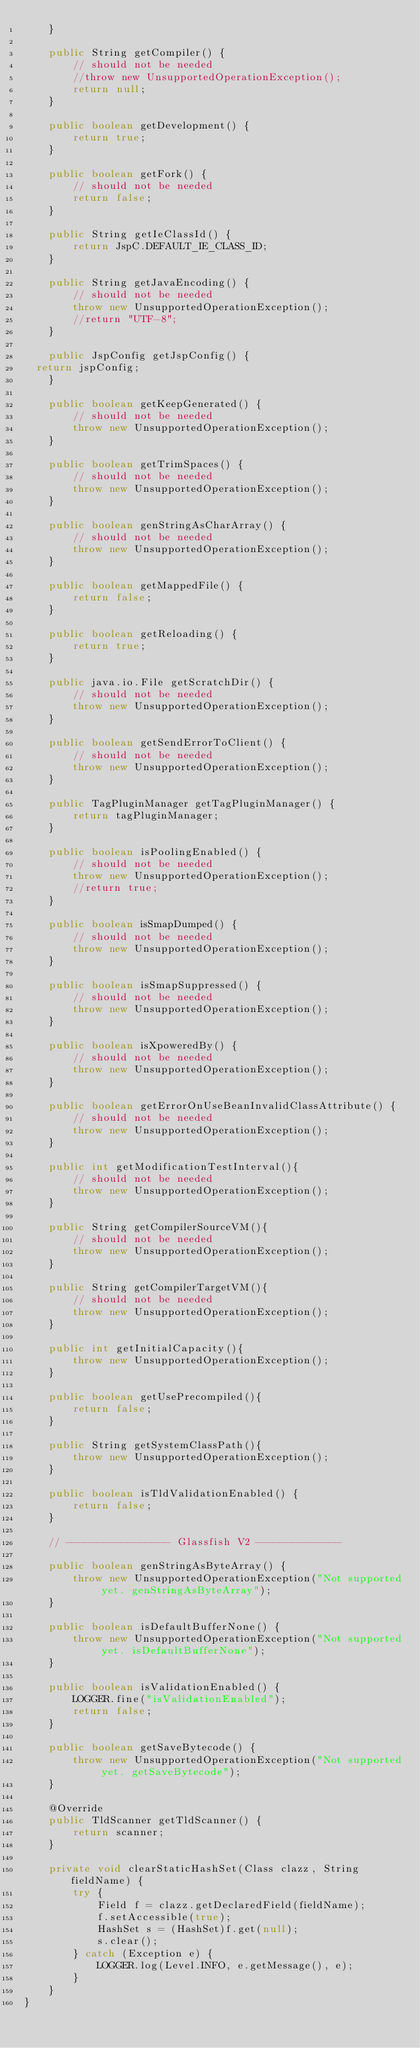Convert code to text. <code><loc_0><loc_0><loc_500><loc_500><_Java_>    }
    
    public String getCompiler() {
        // should not be needed
        //throw new UnsupportedOperationException();
        return null;
    }
    
    public boolean getDevelopment() {
        return true;
    }
    
    public boolean getFork() {
        // should not be needed
        return false;
    }
    
    public String getIeClassId() {
        return JspC.DEFAULT_IE_CLASS_ID;
    }
    
    public String getJavaEncoding() {
        // should not be needed
        throw new UnsupportedOperationException();
        //return "UTF-8";
    }
    
    public JspConfig getJspConfig() {
	return jspConfig;
    }
    
    public boolean getKeepGenerated() {
        // should not be needed
        throw new UnsupportedOperationException();
    }
    
    public boolean getTrimSpaces() {
        // should not be needed
        throw new UnsupportedOperationException();
    }
    
    public boolean genStringAsCharArray() {
        // should not be needed
        throw new UnsupportedOperationException();
    }

    public boolean getMappedFile() {
        return false;
    }
    
    public boolean getReloading() {
        return true;
    }
    
    public java.io.File getScratchDir() {
        // should not be needed
        throw new UnsupportedOperationException();
    }
    
    public boolean getSendErrorToClient() {
        // should not be needed
        throw new UnsupportedOperationException();
    }
    
    public TagPluginManager getTagPluginManager() {
        return tagPluginManager;
    }
    
    public boolean isPoolingEnabled() {
        // should not be needed
        throw new UnsupportedOperationException();
        //return true;
    }
    
    public boolean isSmapDumped() {
        // should not be needed
        throw new UnsupportedOperationException();
    }
    
    public boolean isSmapSuppressed() {
        // should not be needed
        throw new UnsupportedOperationException();
    }
    
    public boolean isXpoweredBy() {
        // should not be needed
        throw new UnsupportedOperationException();
    }
    
    public boolean getErrorOnUseBeanInvalidClassAttribute() {
        // should not be needed
        throw new UnsupportedOperationException();
    }

    public int getModificationTestInterval(){
        // should not be needed
        throw new UnsupportedOperationException();
    }
    
    public String getCompilerSourceVM(){
        // should not be needed
        throw new UnsupportedOperationException();
    }
    
    public String getCompilerTargetVM(){
        // should not be needed
        throw new UnsupportedOperationException();
    }
    
    public int getInitialCapacity(){
        throw new UnsupportedOperationException();
    }
    
    public boolean getUsePrecompiled(){
        return false;
    }
    
    public String getSystemClassPath(){
        throw new UnsupportedOperationException();
    }

    public boolean isTldValidationEnabled() {
        return false;
    }
    
    // ----------------- Glassfish V2 --------------
    
    public boolean genStringAsByteArray() {
        throw new UnsupportedOperationException("Not supported yet. genStringAsByteArray");
    }
    
    public boolean isDefaultBufferNone() {
        throw new UnsupportedOperationException("Not supported yet. isDefaultBufferNone");
    }
    
    public boolean isValidationEnabled() {
        LOGGER.fine("isValidationEnabled");
        return false;
    }
    
    public boolean getSaveBytecode() {
        throw new UnsupportedOperationException("Not supported yet. getSaveBytecode");
    }

    @Override
    public TldScanner getTldScanner() {
        return scanner;
    }

    private void clearStaticHashSet(Class clazz, String fieldName) {
        try {
            Field f = clazz.getDeclaredField(fieldName);
            f.setAccessible(true);
            HashSet s = (HashSet)f.get(null);
            s.clear();
        } catch (Exception e) {
            LOGGER.log(Level.INFO, e.getMessage(), e);
        }
    }
}
</code> 